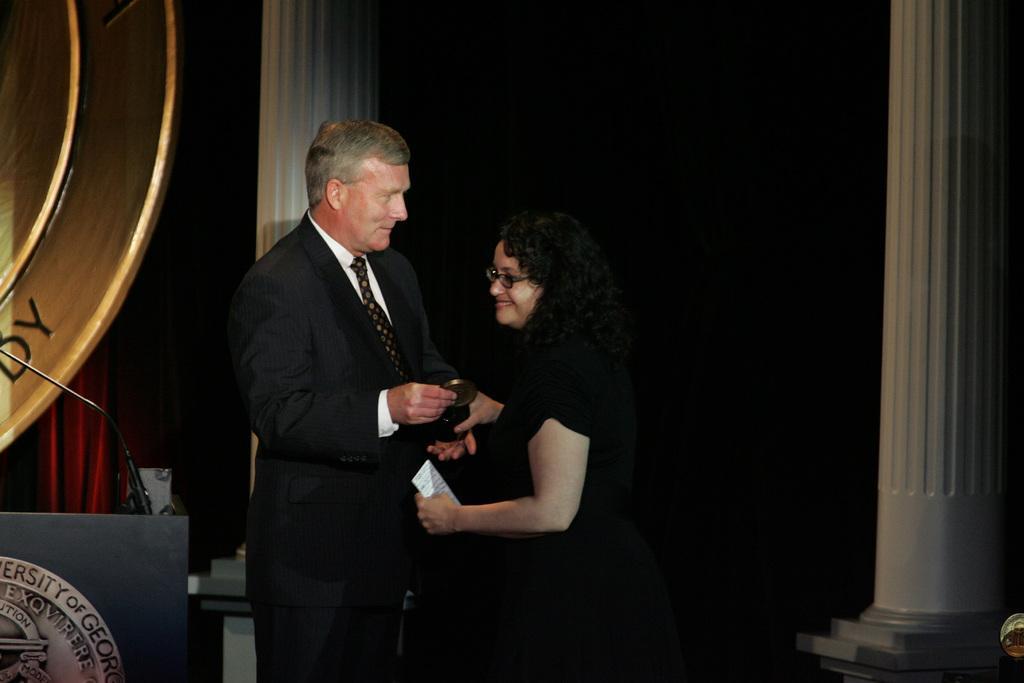How would you summarize this image in a sentence or two? In this image there is a person wearing a suit and tie. Before him there is a woman wearing spectacles. Behind them there is a pillar. Left bottom there is a podium having a mike on it. There is a board. Behind it there is a curtain. Right side there is a pillar. 